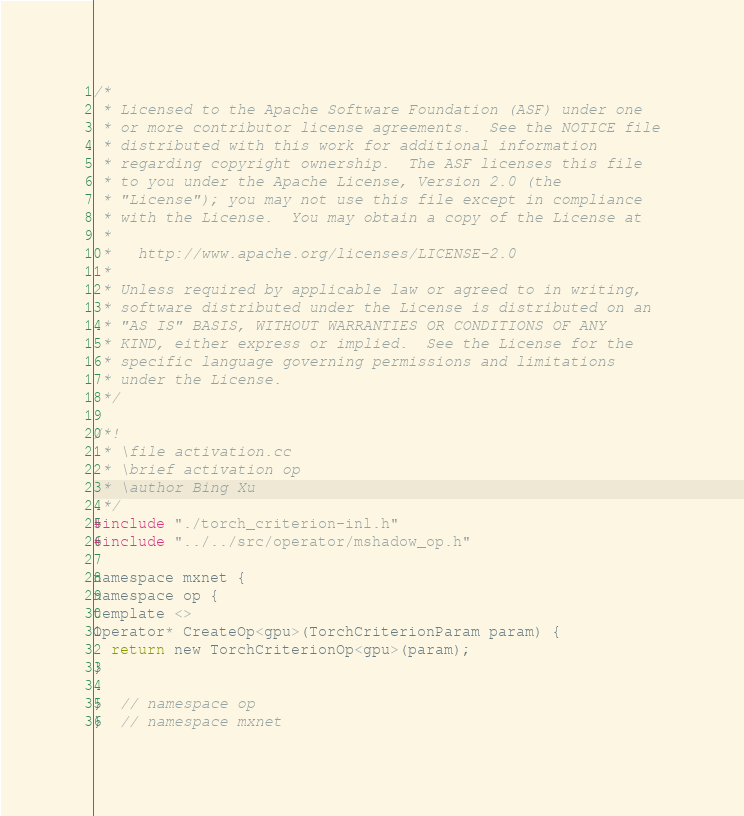<code> <loc_0><loc_0><loc_500><loc_500><_Cuda_>/*
 * Licensed to the Apache Software Foundation (ASF) under one
 * or more contributor license agreements.  See the NOTICE file
 * distributed with this work for additional information
 * regarding copyright ownership.  The ASF licenses this file
 * to you under the Apache License, Version 2.0 (the
 * "License"); you may not use this file except in compliance
 * with the License.  You may obtain a copy of the License at
 *
 *   http://www.apache.org/licenses/LICENSE-2.0
 *
 * Unless required by applicable law or agreed to in writing,
 * software distributed under the License is distributed on an
 * "AS IS" BASIS, WITHOUT WARRANTIES OR CONDITIONS OF ANY
 * KIND, either express or implied.  See the License for the
 * specific language governing permissions and limitations
 * under the License.
 */

/*!
 * \file activation.cc
 * \brief activation op
 * \author Bing Xu
 */
#include "./torch_criterion-inl.h"
#include "../../src/operator/mshadow_op.h"

namespace mxnet {
namespace op {
template <>
Operator* CreateOp<gpu>(TorchCriterionParam param) {
  return new TorchCriterionOp<gpu>(param);
}

}  // namespace op
}  // namespace mxnet
</code> 